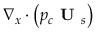Convert formula to latex. <formula><loc_0><loc_0><loc_500><loc_500>\nabla _ { x } \cdot \left ( p _ { c } U _ { s } \right )</formula> 